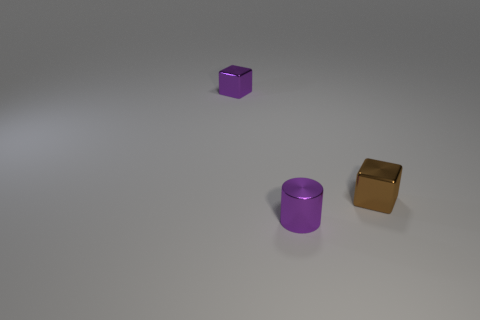There is a tiny cylinder; does it have the same color as the shiny object that is right of the small purple metal cylinder? no 